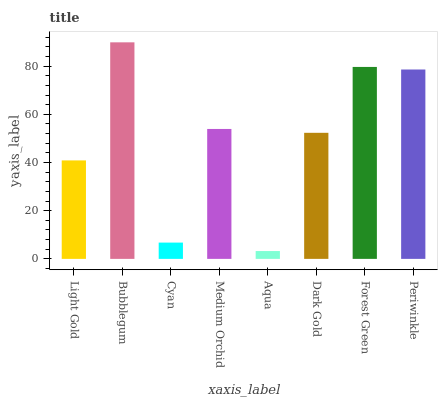Is Cyan the minimum?
Answer yes or no. No. Is Cyan the maximum?
Answer yes or no. No. Is Bubblegum greater than Cyan?
Answer yes or no. Yes. Is Cyan less than Bubblegum?
Answer yes or no. Yes. Is Cyan greater than Bubblegum?
Answer yes or no. No. Is Bubblegum less than Cyan?
Answer yes or no. No. Is Medium Orchid the high median?
Answer yes or no. Yes. Is Dark Gold the low median?
Answer yes or no. Yes. Is Forest Green the high median?
Answer yes or no. No. Is Aqua the low median?
Answer yes or no. No. 